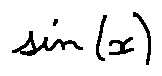Convert formula to latex. <formula><loc_0><loc_0><loc_500><loc_500>\sin ( x )</formula> 